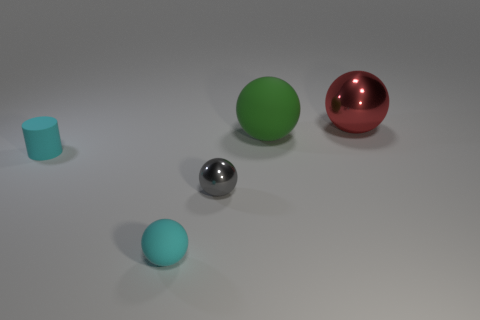How many small gray shiny objects are on the right side of the matte object that is to the right of the gray object?
Give a very brief answer. 0. How many large metal objects are there?
Give a very brief answer. 1. Is the material of the large green sphere the same as the thing behind the green rubber thing?
Provide a succinct answer. No. There is a matte sphere that is in front of the large matte thing; does it have the same color as the small matte cylinder?
Your answer should be compact. Yes. There is a ball that is in front of the red ball and behind the gray ball; what material is it?
Your response must be concise. Rubber. What is the size of the cylinder?
Your answer should be compact. Small. Is the color of the small matte sphere the same as the tiny thing that is behind the tiny gray shiny sphere?
Ensure brevity in your answer.  Yes. How many other things are there of the same color as the small shiny ball?
Your answer should be compact. 0. There is a shiny object right of the green object; is its size the same as the shiny object left of the red sphere?
Offer a terse response. No. What color is the shiny ball behind the small gray ball?
Make the answer very short. Red. 